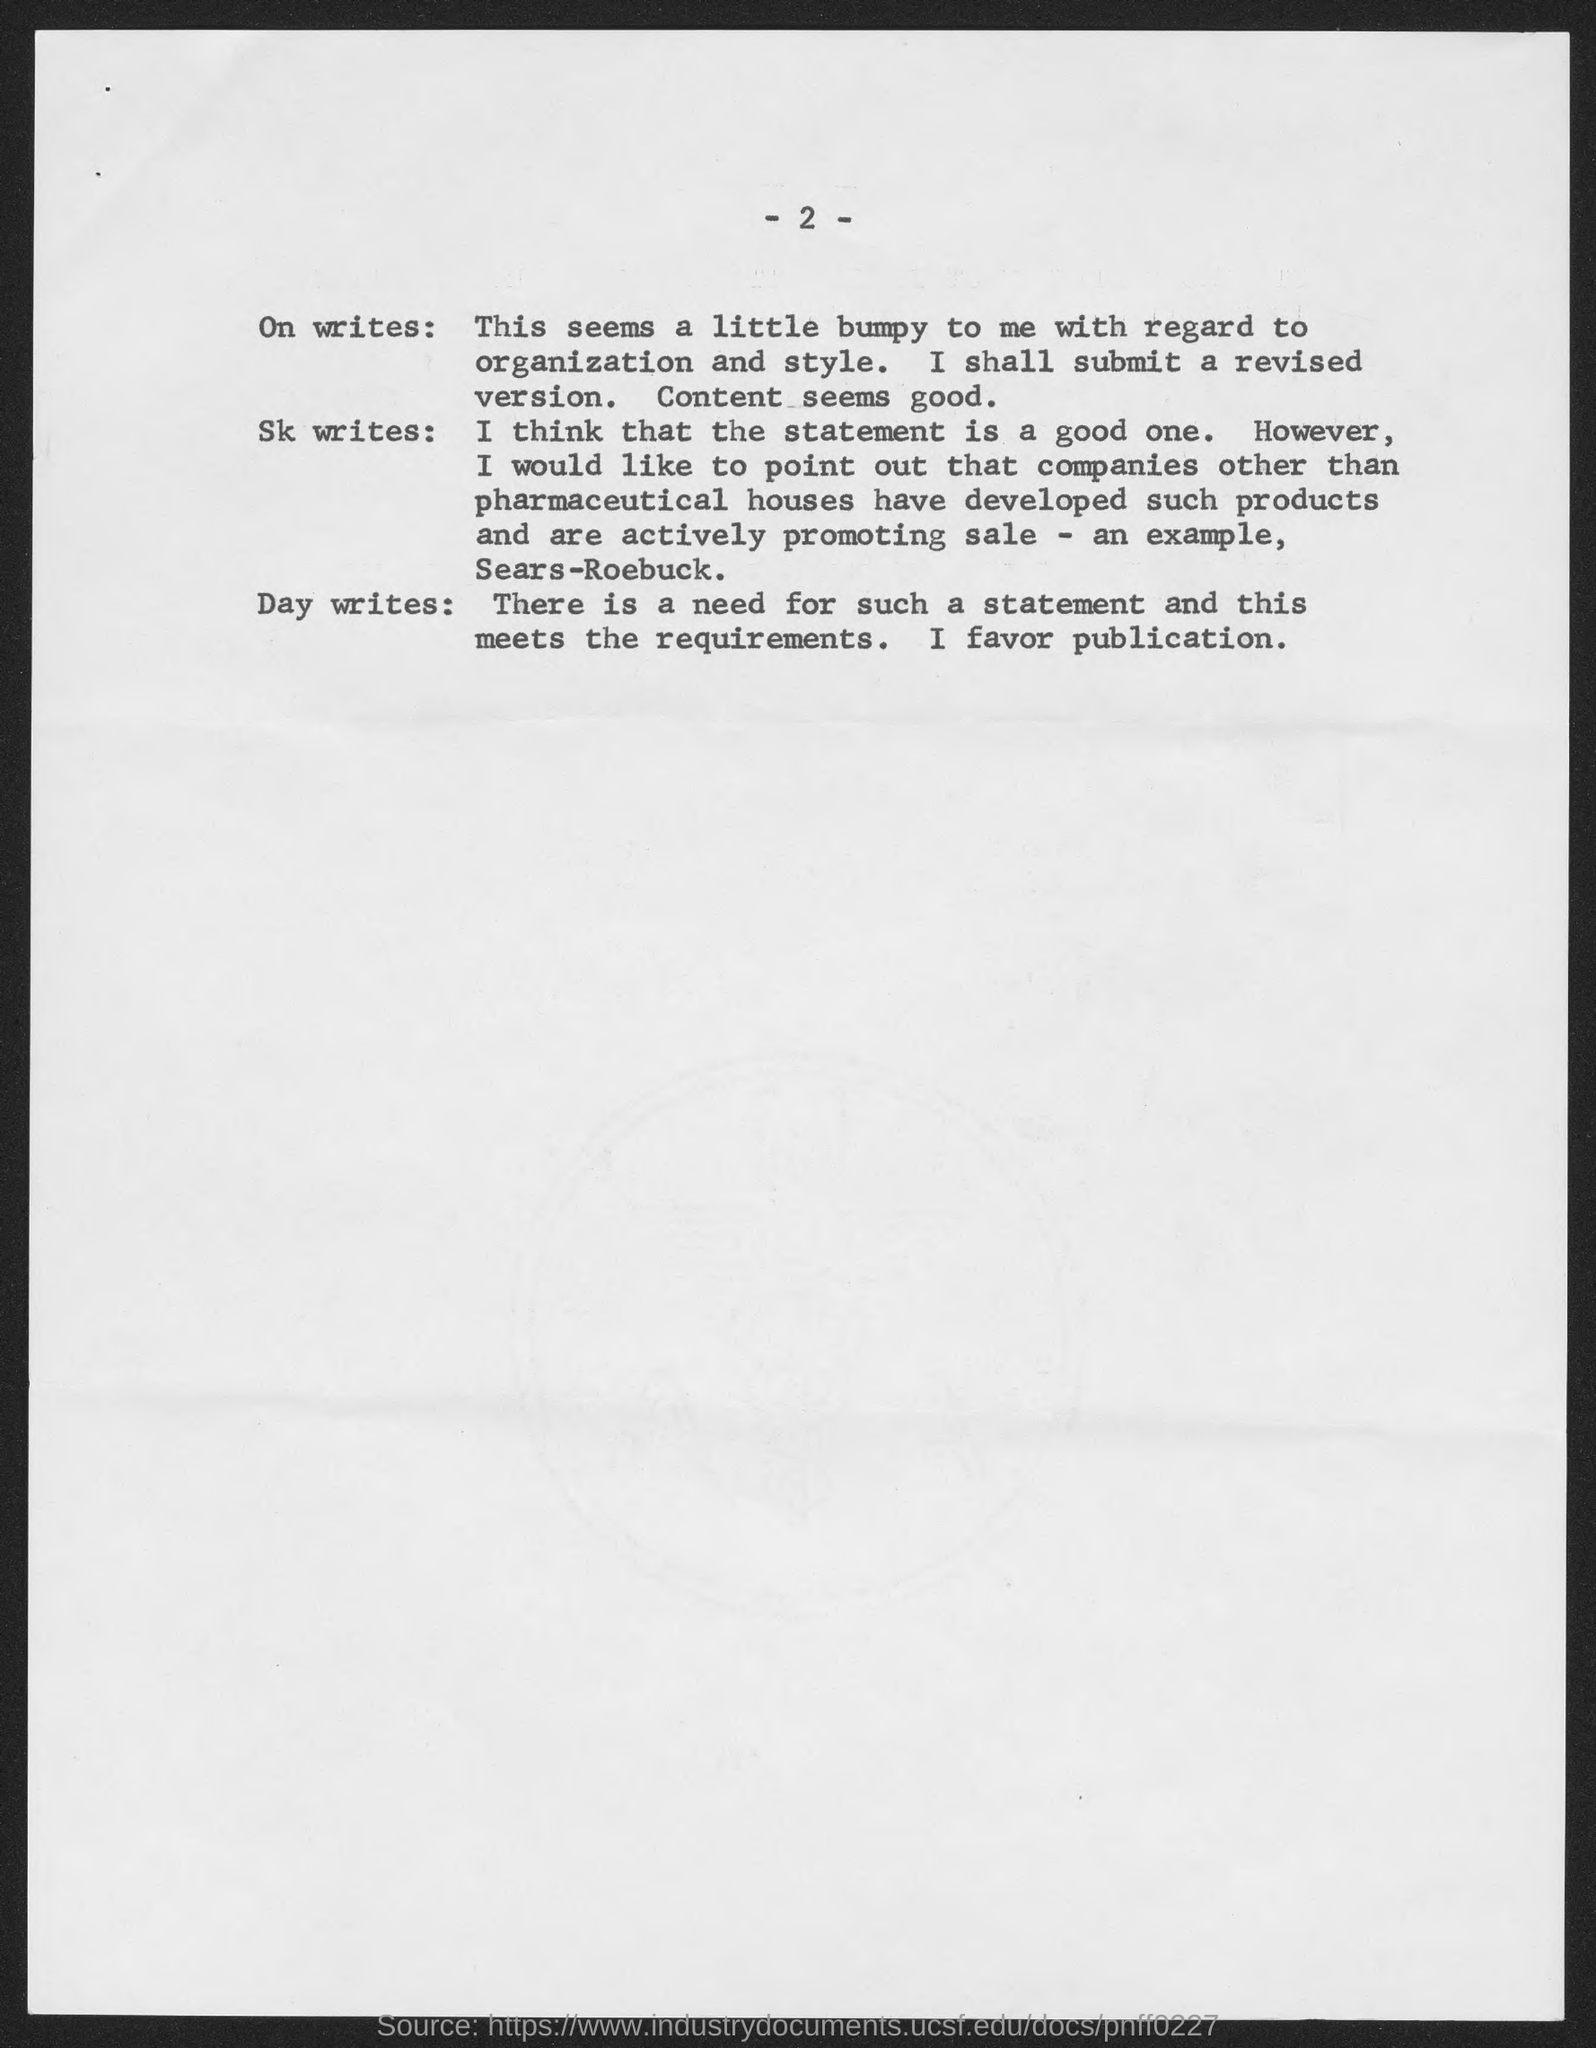What is the page no mentioned in this document?
Offer a very short reply. -2-. 